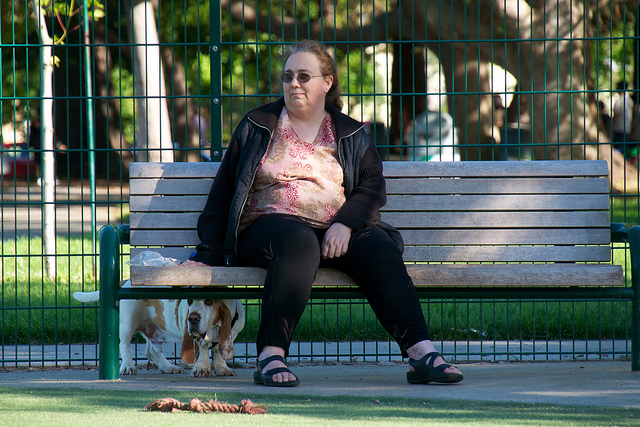What dog breed does the woman have?
A. pug
B. bassett hound
C. dachshund
D. shiba inu The woman appears to be with a dog that is characteristic of the Basset Hound breed. Basset Hounds are known for their long, droopy ears and short, statured legs, which can be seen in the image. They are quite distinct from Pugs, Dachshunds, and Shiba Inus, each of which has a very different body shape and ear type. 